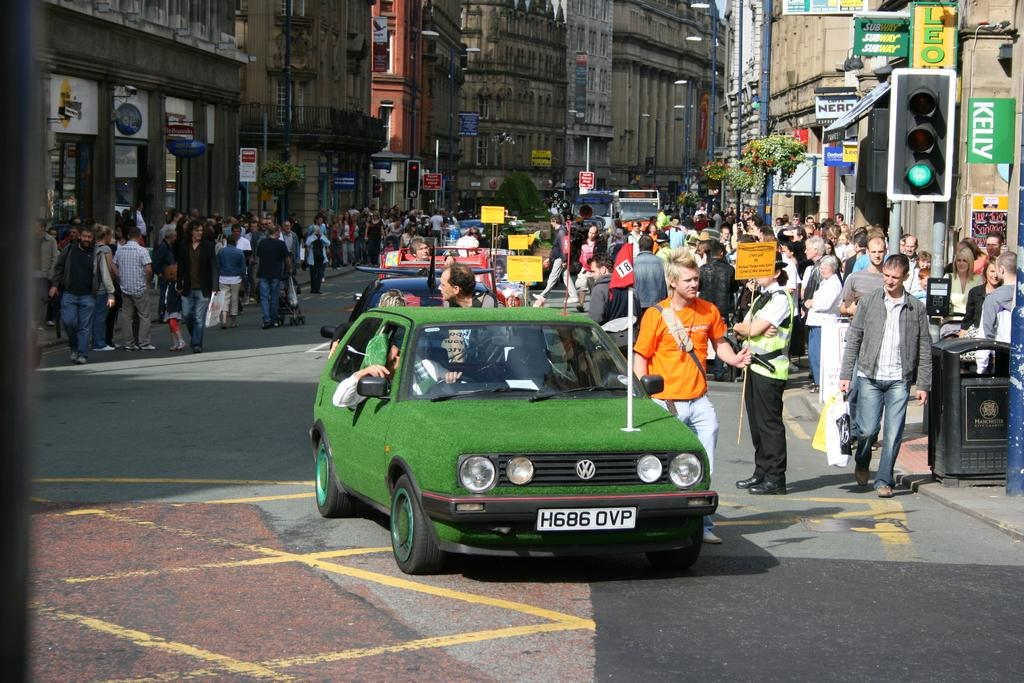Provide a one-sentence caption for the provided image. A car that has been made to look like a putting green and has the licence plate h686ovp on it. 